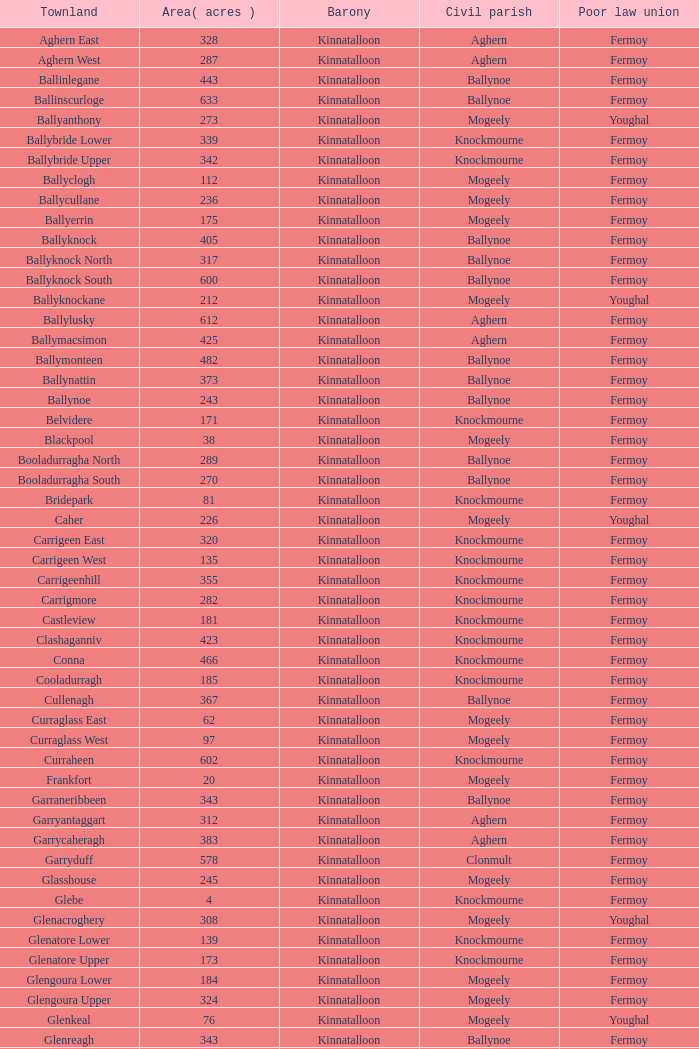What is the region for the civil parishes of ballynoe and killasseragh? 340.0. 